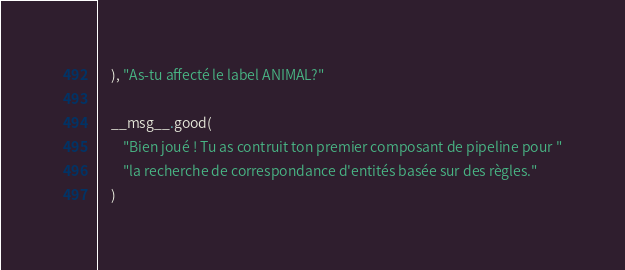Convert code to text. <code><loc_0><loc_0><loc_500><loc_500><_Python_>    ), "As-tu affecté le label ANIMAL?"

    __msg__.good(
        "Bien joué ! Tu as contruit ton premier composant de pipeline pour "
        "la recherche de correspondance d'entités basée sur des règles."
    )
</code> 